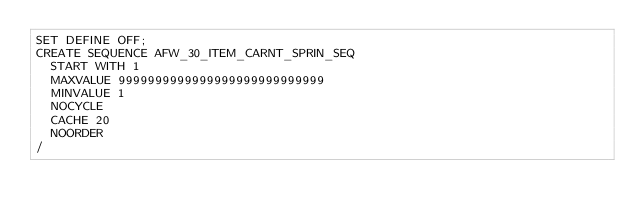Convert code to text. <code><loc_0><loc_0><loc_500><loc_500><_SQL_>SET DEFINE OFF;
CREATE SEQUENCE AFW_30_ITEM_CARNT_SPRIN_SEQ
  START WITH 1
  MAXVALUE 9999999999999999999999999999
  MINVALUE 1
  NOCYCLE
  CACHE 20
  NOORDER
/
</code> 